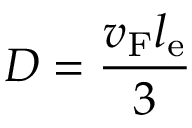Convert formula to latex. <formula><loc_0><loc_0><loc_500><loc_500>D = \frac { v _ { F } l _ { e } } { 3 }</formula> 